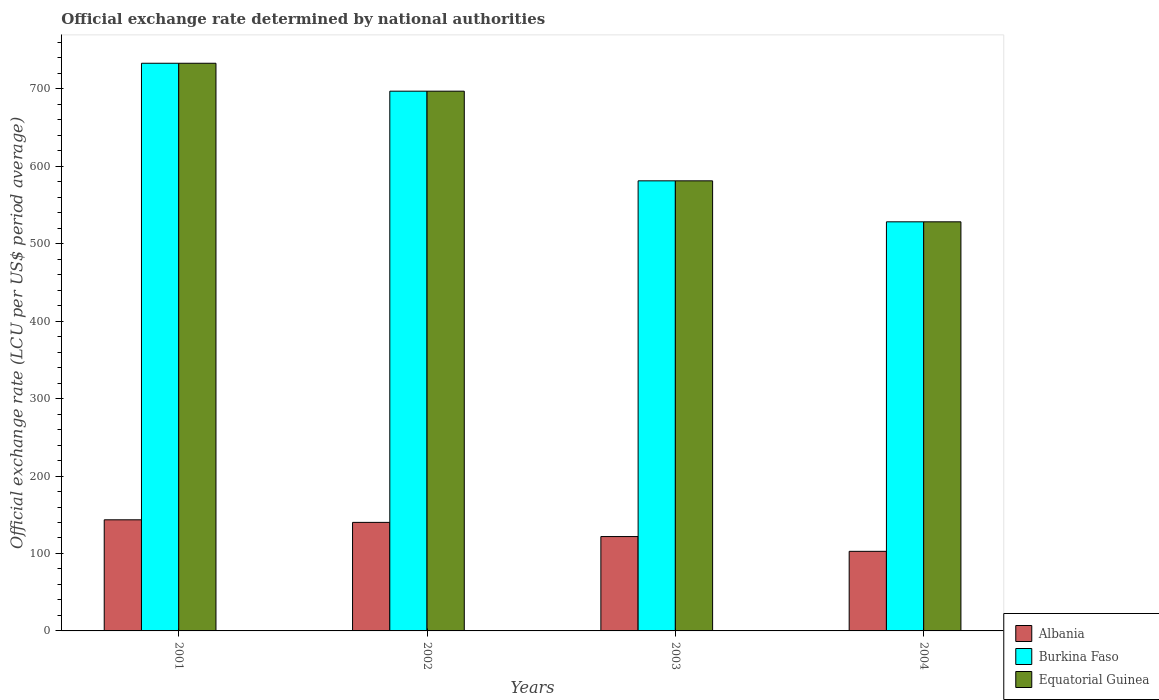How many different coloured bars are there?
Your answer should be compact. 3. Are the number of bars per tick equal to the number of legend labels?
Offer a very short reply. Yes. How many bars are there on the 1st tick from the left?
Make the answer very short. 3. What is the official exchange rate in Equatorial Guinea in 2004?
Offer a terse response. 528.28. Across all years, what is the maximum official exchange rate in Equatorial Guinea?
Provide a short and direct response. 733.04. Across all years, what is the minimum official exchange rate in Burkina Faso?
Your answer should be compact. 528.28. In which year was the official exchange rate in Albania maximum?
Provide a short and direct response. 2001. In which year was the official exchange rate in Albania minimum?
Your answer should be very brief. 2004. What is the total official exchange rate in Albania in the graph?
Offer a very short reply. 508.28. What is the difference between the official exchange rate in Albania in 2001 and that in 2003?
Give a very brief answer. 21.62. What is the difference between the official exchange rate in Equatorial Guinea in 2002 and the official exchange rate in Albania in 2004?
Your answer should be very brief. 594.21. What is the average official exchange rate in Burkina Faso per year?
Offer a very short reply. 634.88. In the year 2002, what is the difference between the official exchange rate in Albania and official exchange rate in Burkina Faso?
Give a very brief answer. -556.83. What is the ratio of the official exchange rate in Albania in 2002 to that in 2003?
Offer a very short reply. 1.15. Is the official exchange rate in Albania in 2001 less than that in 2002?
Give a very brief answer. No. Is the difference between the official exchange rate in Albania in 2002 and 2003 greater than the difference between the official exchange rate in Burkina Faso in 2002 and 2003?
Ensure brevity in your answer.  No. What is the difference between the highest and the second highest official exchange rate in Equatorial Guinea?
Your answer should be compact. 36.05. What is the difference between the highest and the lowest official exchange rate in Burkina Faso?
Your response must be concise. 204.75. Is the sum of the official exchange rate in Equatorial Guinea in 2002 and 2004 greater than the maximum official exchange rate in Albania across all years?
Provide a short and direct response. Yes. What does the 1st bar from the left in 2002 represents?
Your response must be concise. Albania. What does the 2nd bar from the right in 2004 represents?
Make the answer very short. Burkina Faso. Are all the bars in the graph horizontal?
Provide a short and direct response. No. Does the graph contain any zero values?
Provide a short and direct response. No. Does the graph contain grids?
Your answer should be compact. No. Where does the legend appear in the graph?
Ensure brevity in your answer.  Bottom right. How are the legend labels stacked?
Offer a very short reply. Vertical. What is the title of the graph?
Your response must be concise. Official exchange rate determined by national authorities. What is the label or title of the X-axis?
Offer a very short reply. Years. What is the label or title of the Y-axis?
Make the answer very short. Official exchange rate (LCU per US$ period average). What is the Official exchange rate (LCU per US$ period average) in Albania in 2001?
Give a very brief answer. 143.48. What is the Official exchange rate (LCU per US$ period average) of Burkina Faso in 2001?
Your response must be concise. 733.04. What is the Official exchange rate (LCU per US$ period average) in Equatorial Guinea in 2001?
Provide a succinct answer. 733.04. What is the Official exchange rate (LCU per US$ period average) of Albania in 2002?
Keep it short and to the point. 140.15. What is the Official exchange rate (LCU per US$ period average) of Burkina Faso in 2002?
Provide a short and direct response. 696.99. What is the Official exchange rate (LCU per US$ period average) in Equatorial Guinea in 2002?
Provide a short and direct response. 696.99. What is the Official exchange rate (LCU per US$ period average) of Albania in 2003?
Ensure brevity in your answer.  121.86. What is the Official exchange rate (LCU per US$ period average) of Burkina Faso in 2003?
Offer a terse response. 581.2. What is the Official exchange rate (LCU per US$ period average) in Equatorial Guinea in 2003?
Provide a succinct answer. 581.2. What is the Official exchange rate (LCU per US$ period average) of Albania in 2004?
Your answer should be very brief. 102.78. What is the Official exchange rate (LCU per US$ period average) of Burkina Faso in 2004?
Your response must be concise. 528.28. What is the Official exchange rate (LCU per US$ period average) of Equatorial Guinea in 2004?
Make the answer very short. 528.28. Across all years, what is the maximum Official exchange rate (LCU per US$ period average) of Albania?
Your answer should be compact. 143.48. Across all years, what is the maximum Official exchange rate (LCU per US$ period average) in Burkina Faso?
Provide a short and direct response. 733.04. Across all years, what is the maximum Official exchange rate (LCU per US$ period average) of Equatorial Guinea?
Make the answer very short. 733.04. Across all years, what is the minimum Official exchange rate (LCU per US$ period average) in Albania?
Ensure brevity in your answer.  102.78. Across all years, what is the minimum Official exchange rate (LCU per US$ period average) in Burkina Faso?
Your response must be concise. 528.28. Across all years, what is the minimum Official exchange rate (LCU per US$ period average) of Equatorial Guinea?
Give a very brief answer. 528.28. What is the total Official exchange rate (LCU per US$ period average) of Albania in the graph?
Keep it short and to the point. 508.28. What is the total Official exchange rate (LCU per US$ period average) of Burkina Faso in the graph?
Your answer should be very brief. 2539.51. What is the total Official exchange rate (LCU per US$ period average) of Equatorial Guinea in the graph?
Your answer should be compact. 2539.51. What is the difference between the Official exchange rate (LCU per US$ period average) in Albania in 2001 and that in 2002?
Offer a very short reply. 3.33. What is the difference between the Official exchange rate (LCU per US$ period average) in Burkina Faso in 2001 and that in 2002?
Make the answer very short. 36.05. What is the difference between the Official exchange rate (LCU per US$ period average) of Equatorial Guinea in 2001 and that in 2002?
Provide a short and direct response. 36.05. What is the difference between the Official exchange rate (LCU per US$ period average) of Albania in 2001 and that in 2003?
Keep it short and to the point. 21.62. What is the difference between the Official exchange rate (LCU per US$ period average) in Burkina Faso in 2001 and that in 2003?
Your answer should be very brief. 151.84. What is the difference between the Official exchange rate (LCU per US$ period average) of Equatorial Guinea in 2001 and that in 2003?
Your response must be concise. 151.84. What is the difference between the Official exchange rate (LCU per US$ period average) in Albania in 2001 and that in 2004?
Your response must be concise. 40.7. What is the difference between the Official exchange rate (LCU per US$ period average) of Burkina Faso in 2001 and that in 2004?
Provide a succinct answer. 204.75. What is the difference between the Official exchange rate (LCU per US$ period average) in Equatorial Guinea in 2001 and that in 2004?
Make the answer very short. 204.75. What is the difference between the Official exchange rate (LCU per US$ period average) in Albania in 2002 and that in 2003?
Offer a terse response. 18.29. What is the difference between the Official exchange rate (LCU per US$ period average) in Burkina Faso in 2002 and that in 2003?
Offer a very short reply. 115.79. What is the difference between the Official exchange rate (LCU per US$ period average) of Equatorial Guinea in 2002 and that in 2003?
Offer a terse response. 115.79. What is the difference between the Official exchange rate (LCU per US$ period average) of Albania in 2002 and that in 2004?
Provide a succinct answer. 37.37. What is the difference between the Official exchange rate (LCU per US$ period average) in Burkina Faso in 2002 and that in 2004?
Give a very brief answer. 168.7. What is the difference between the Official exchange rate (LCU per US$ period average) of Equatorial Guinea in 2002 and that in 2004?
Make the answer very short. 168.7. What is the difference between the Official exchange rate (LCU per US$ period average) in Albania in 2003 and that in 2004?
Make the answer very short. 19.08. What is the difference between the Official exchange rate (LCU per US$ period average) in Burkina Faso in 2003 and that in 2004?
Provide a succinct answer. 52.92. What is the difference between the Official exchange rate (LCU per US$ period average) of Equatorial Guinea in 2003 and that in 2004?
Give a very brief answer. 52.92. What is the difference between the Official exchange rate (LCU per US$ period average) of Albania in 2001 and the Official exchange rate (LCU per US$ period average) of Burkina Faso in 2002?
Ensure brevity in your answer.  -553.5. What is the difference between the Official exchange rate (LCU per US$ period average) in Albania in 2001 and the Official exchange rate (LCU per US$ period average) in Equatorial Guinea in 2002?
Your answer should be very brief. -553.5. What is the difference between the Official exchange rate (LCU per US$ period average) of Burkina Faso in 2001 and the Official exchange rate (LCU per US$ period average) of Equatorial Guinea in 2002?
Provide a succinct answer. 36.05. What is the difference between the Official exchange rate (LCU per US$ period average) in Albania in 2001 and the Official exchange rate (LCU per US$ period average) in Burkina Faso in 2003?
Ensure brevity in your answer.  -437.72. What is the difference between the Official exchange rate (LCU per US$ period average) of Albania in 2001 and the Official exchange rate (LCU per US$ period average) of Equatorial Guinea in 2003?
Your response must be concise. -437.72. What is the difference between the Official exchange rate (LCU per US$ period average) in Burkina Faso in 2001 and the Official exchange rate (LCU per US$ period average) in Equatorial Guinea in 2003?
Make the answer very short. 151.84. What is the difference between the Official exchange rate (LCU per US$ period average) in Albania in 2001 and the Official exchange rate (LCU per US$ period average) in Burkina Faso in 2004?
Make the answer very short. -384.8. What is the difference between the Official exchange rate (LCU per US$ period average) in Albania in 2001 and the Official exchange rate (LCU per US$ period average) in Equatorial Guinea in 2004?
Your answer should be compact. -384.8. What is the difference between the Official exchange rate (LCU per US$ period average) of Burkina Faso in 2001 and the Official exchange rate (LCU per US$ period average) of Equatorial Guinea in 2004?
Keep it short and to the point. 204.75. What is the difference between the Official exchange rate (LCU per US$ period average) of Albania in 2002 and the Official exchange rate (LCU per US$ period average) of Burkina Faso in 2003?
Offer a terse response. -441.05. What is the difference between the Official exchange rate (LCU per US$ period average) of Albania in 2002 and the Official exchange rate (LCU per US$ period average) of Equatorial Guinea in 2003?
Offer a very short reply. -441.05. What is the difference between the Official exchange rate (LCU per US$ period average) in Burkina Faso in 2002 and the Official exchange rate (LCU per US$ period average) in Equatorial Guinea in 2003?
Provide a short and direct response. 115.79. What is the difference between the Official exchange rate (LCU per US$ period average) of Albania in 2002 and the Official exchange rate (LCU per US$ period average) of Burkina Faso in 2004?
Provide a short and direct response. -388.13. What is the difference between the Official exchange rate (LCU per US$ period average) of Albania in 2002 and the Official exchange rate (LCU per US$ period average) of Equatorial Guinea in 2004?
Keep it short and to the point. -388.13. What is the difference between the Official exchange rate (LCU per US$ period average) in Burkina Faso in 2002 and the Official exchange rate (LCU per US$ period average) in Equatorial Guinea in 2004?
Ensure brevity in your answer.  168.7. What is the difference between the Official exchange rate (LCU per US$ period average) in Albania in 2003 and the Official exchange rate (LCU per US$ period average) in Burkina Faso in 2004?
Give a very brief answer. -406.42. What is the difference between the Official exchange rate (LCU per US$ period average) of Albania in 2003 and the Official exchange rate (LCU per US$ period average) of Equatorial Guinea in 2004?
Provide a succinct answer. -406.42. What is the difference between the Official exchange rate (LCU per US$ period average) of Burkina Faso in 2003 and the Official exchange rate (LCU per US$ period average) of Equatorial Guinea in 2004?
Provide a short and direct response. 52.92. What is the average Official exchange rate (LCU per US$ period average) of Albania per year?
Keep it short and to the point. 127.07. What is the average Official exchange rate (LCU per US$ period average) in Burkina Faso per year?
Your response must be concise. 634.88. What is the average Official exchange rate (LCU per US$ period average) in Equatorial Guinea per year?
Provide a short and direct response. 634.88. In the year 2001, what is the difference between the Official exchange rate (LCU per US$ period average) in Albania and Official exchange rate (LCU per US$ period average) in Burkina Faso?
Your response must be concise. -589.55. In the year 2001, what is the difference between the Official exchange rate (LCU per US$ period average) in Albania and Official exchange rate (LCU per US$ period average) in Equatorial Guinea?
Ensure brevity in your answer.  -589.55. In the year 2001, what is the difference between the Official exchange rate (LCU per US$ period average) in Burkina Faso and Official exchange rate (LCU per US$ period average) in Equatorial Guinea?
Provide a succinct answer. 0. In the year 2002, what is the difference between the Official exchange rate (LCU per US$ period average) of Albania and Official exchange rate (LCU per US$ period average) of Burkina Faso?
Ensure brevity in your answer.  -556.83. In the year 2002, what is the difference between the Official exchange rate (LCU per US$ period average) in Albania and Official exchange rate (LCU per US$ period average) in Equatorial Guinea?
Ensure brevity in your answer.  -556.83. In the year 2002, what is the difference between the Official exchange rate (LCU per US$ period average) of Burkina Faso and Official exchange rate (LCU per US$ period average) of Equatorial Guinea?
Offer a very short reply. 0. In the year 2003, what is the difference between the Official exchange rate (LCU per US$ period average) of Albania and Official exchange rate (LCU per US$ period average) of Burkina Faso?
Keep it short and to the point. -459.34. In the year 2003, what is the difference between the Official exchange rate (LCU per US$ period average) in Albania and Official exchange rate (LCU per US$ period average) in Equatorial Guinea?
Ensure brevity in your answer.  -459.34. In the year 2003, what is the difference between the Official exchange rate (LCU per US$ period average) of Burkina Faso and Official exchange rate (LCU per US$ period average) of Equatorial Guinea?
Your response must be concise. 0. In the year 2004, what is the difference between the Official exchange rate (LCU per US$ period average) in Albania and Official exchange rate (LCU per US$ period average) in Burkina Faso?
Make the answer very short. -425.5. In the year 2004, what is the difference between the Official exchange rate (LCU per US$ period average) of Albania and Official exchange rate (LCU per US$ period average) of Equatorial Guinea?
Provide a succinct answer. -425.5. What is the ratio of the Official exchange rate (LCU per US$ period average) in Albania in 2001 to that in 2002?
Your response must be concise. 1.02. What is the ratio of the Official exchange rate (LCU per US$ period average) in Burkina Faso in 2001 to that in 2002?
Offer a terse response. 1.05. What is the ratio of the Official exchange rate (LCU per US$ period average) in Equatorial Guinea in 2001 to that in 2002?
Keep it short and to the point. 1.05. What is the ratio of the Official exchange rate (LCU per US$ period average) in Albania in 2001 to that in 2003?
Provide a succinct answer. 1.18. What is the ratio of the Official exchange rate (LCU per US$ period average) in Burkina Faso in 2001 to that in 2003?
Offer a terse response. 1.26. What is the ratio of the Official exchange rate (LCU per US$ period average) in Equatorial Guinea in 2001 to that in 2003?
Provide a short and direct response. 1.26. What is the ratio of the Official exchange rate (LCU per US$ period average) in Albania in 2001 to that in 2004?
Your answer should be compact. 1.4. What is the ratio of the Official exchange rate (LCU per US$ period average) in Burkina Faso in 2001 to that in 2004?
Your response must be concise. 1.39. What is the ratio of the Official exchange rate (LCU per US$ period average) of Equatorial Guinea in 2001 to that in 2004?
Provide a succinct answer. 1.39. What is the ratio of the Official exchange rate (LCU per US$ period average) in Albania in 2002 to that in 2003?
Offer a terse response. 1.15. What is the ratio of the Official exchange rate (LCU per US$ period average) of Burkina Faso in 2002 to that in 2003?
Make the answer very short. 1.2. What is the ratio of the Official exchange rate (LCU per US$ period average) in Equatorial Guinea in 2002 to that in 2003?
Provide a short and direct response. 1.2. What is the ratio of the Official exchange rate (LCU per US$ period average) of Albania in 2002 to that in 2004?
Ensure brevity in your answer.  1.36. What is the ratio of the Official exchange rate (LCU per US$ period average) in Burkina Faso in 2002 to that in 2004?
Your answer should be compact. 1.32. What is the ratio of the Official exchange rate (LCU per US$ period average) in Equatorial Guinea in 2002 to that in 2004?
Provide a short and direct response. 1.32. What is the ratio of the Official exchange rate (LCU per US$ period average) in Albania in 2003 to that in 2004?
Your answer should be very brief. 1.19. What is the ratio of the Official exchange rate (LCU per US$ period average) of Burkina Faso in 2003 to that in 2004?
Your answer should be very brief. 1.1. What is the ratio of the Official exchange rate (LCU per US$ period average) in Equatorial Guinea in 2003 to that in 2004?
Give a very brief answer. 1.1. What is the difference between the highest and the second highest Official exchange rate (LCU per US$ period average) of Albania?
Your response must be concise. 3.33. What is the difference between the highest and the second highest Official exchange rate (LCU per US$ period average) in Burkina Faso?
Make the answer very short. 36.05. What is the difference between the highest and the second highest Official exchange rate (LCU per US$ period average) in Equatorial Guinea?
Your response must be concise. 36.05. What is the difference between the highest and the lowest Official exchange rate (LCU per US$ period average) of Albania?
Make the answer very short. 40.7. What is the difference between the highest and the lowest Official exchange rate (LCU per US$ period average) in Burkina Faso?
Give a very brief answer. 204.75. What is the difference between the highest and the lowest Official exchange rate (LCU per US$ period average) of Equatorial Guinea?
Offer a very short reply. 204.75. 